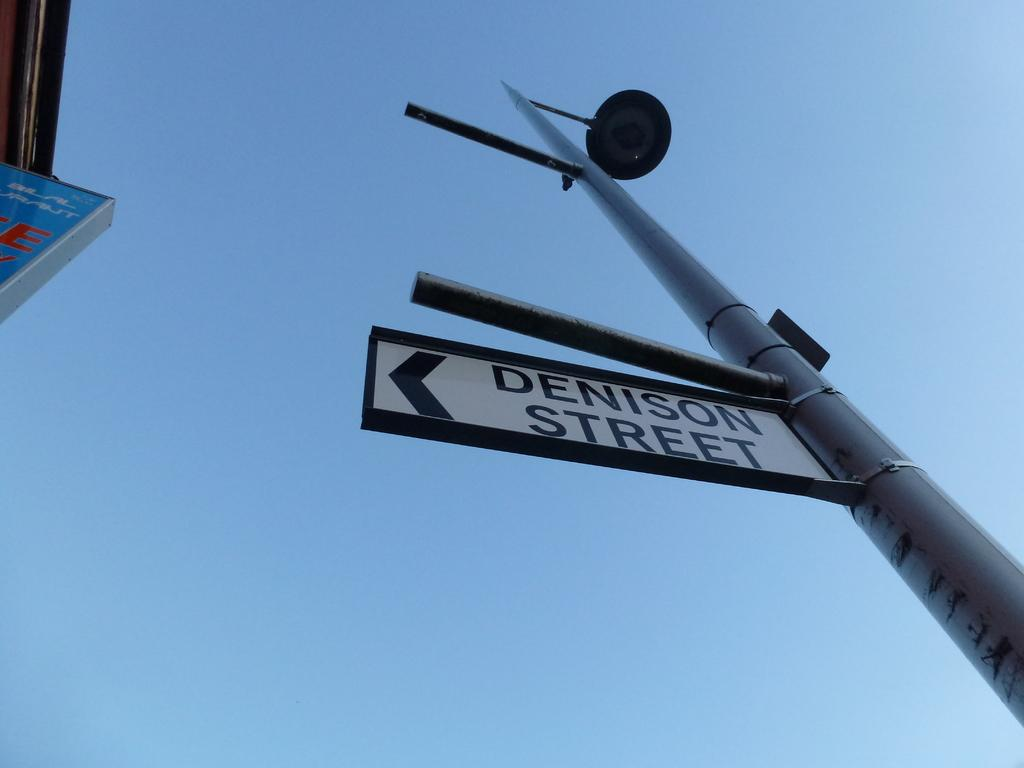<image>
Provide a brief description of the given image. A street sign with and arrow and words Denison Street. 